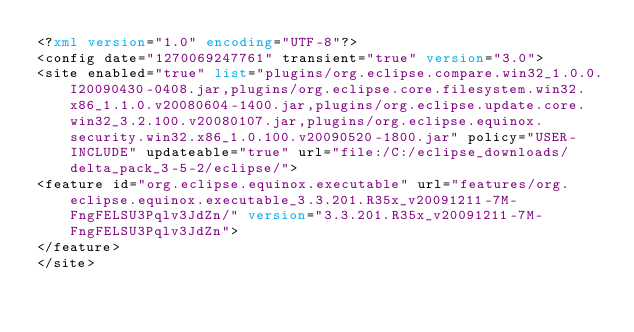<code> <loc_0><loc_0><loc_500><loc_500><_XML_><?xml version="1.0" encoding="UTF-8"?>
<config date="1270069247761" transient="true" version="3.0">
<site enabled="true" list="plugins/org.eclipse.compare.win32_1.0.0.I20090430-0408.jar,plugins/org.eclipse.core.filesystem.win32.x86_1.1.0.v20080604-1400.jar,plugins/org.eclipse.update.core.win32_3.2.100.v20080107.jar,plugins/org.eclipse.equinox.security.win32.x86_1.0.100.v20090520-1800.jar" policy="USER-INCLUDE" updateable="true" url="file:/C:/eclipse_downloads/delta_pack_3-5-2/eclipse/">
<feature id="org.eclipse.equinox.executable" url="features/org.eclipse.equinox.executable_3.3.201.R35x_v20091211-7M-FngFELSU3Pqlv3JdZn/" version="3.3.201.R35x_v20091211-7M-FngFELSU3Pqlv3JdZn">
</feature>
</site></code> 